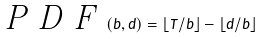Convert formula to latex. <formula><loc_0><loc_0><loc_500><loc_500>\emph { P D F } ( b , d ) = \lfloor { T / b } \rfloor - \lfloor { d / b } \rfloor</formula> 